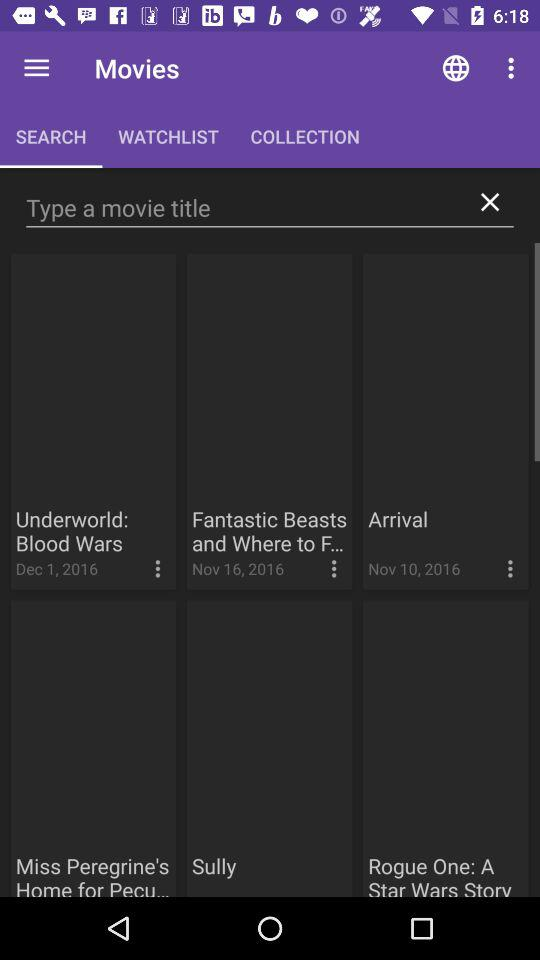Which tab is selected? The selected tab is "SEARCH". 